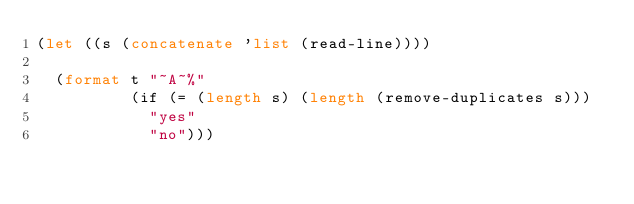<code> <loc_0><loc_0><loc_500><loc_500><_Lisp_>(let ((s (concatenate 'list (read-line))))

  (format t "~A~%"
          (if (= (length s) (length (remove-duplicates s)))
            "yes"
            "no")))
</code> 